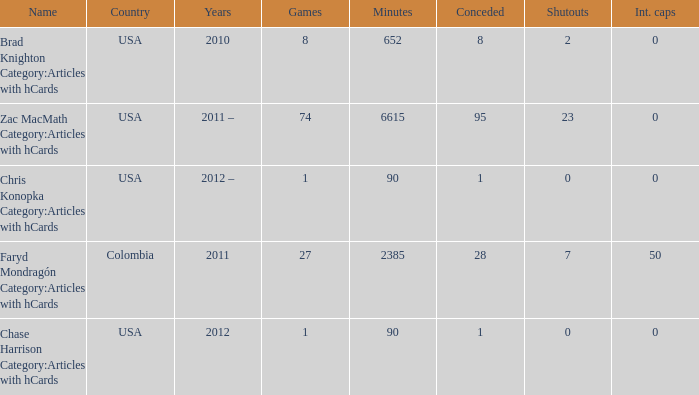When chase harrison category:articles with hcards is the name what is the year? 2012.0. 